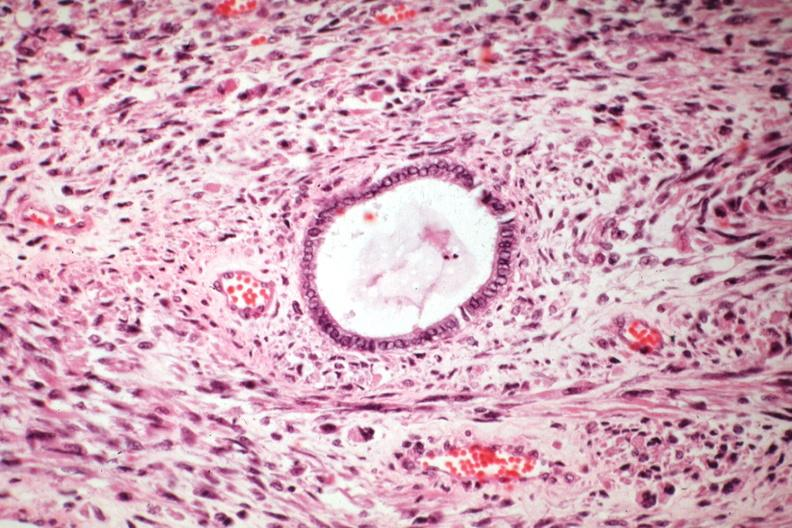s notochord present?
Answer the question using a single word or phrase. No 